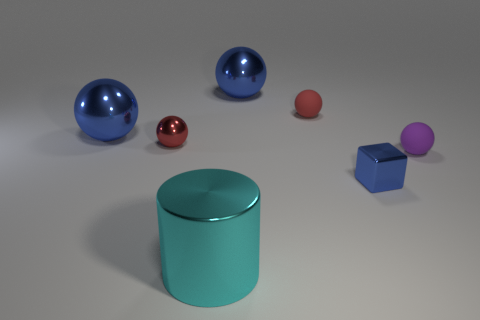What number of blue cylinders are the same size as the metal cube?
Keep it short and to the point. 0. The tiny object that is the same color as the tiny metal ball is what shape?
Ensure brevity in your answer.  Sphere. What number of objects are either red matte objects or spheres right of the large cyan metallic thing?
Offer a terse response. 3. Is the size of the rubber ball left of the purple object the same as the blue thing in front of the tiny purple matte thing?
Provide a succinct answer. Yes. How many tiny purple objects have the same shape as the small blue object?
Keep it short and to the point. 0. What is the shape of the small blue thing that is the same material as the cyan cylinder?
Your answer should be very brief. Cube. What is the material of the ball right of the small shiny thing to the right of the rubber ball left of the purple matte thing?
Provide a short and direct response. Rubber. There is a cube; is its size the same as the shiny object that is in front of the small blue metal object?
Give a very brief answer. No. There is another red thing that is the same shape as the tiny red shiny thing; what is it made of?
Provide a short and direct response. Rubber. What is the size of the object that is right of the small blue metal block right of the large metallic thing that is on the right side of the cyan object?
Provide a short and direct response. Small. 